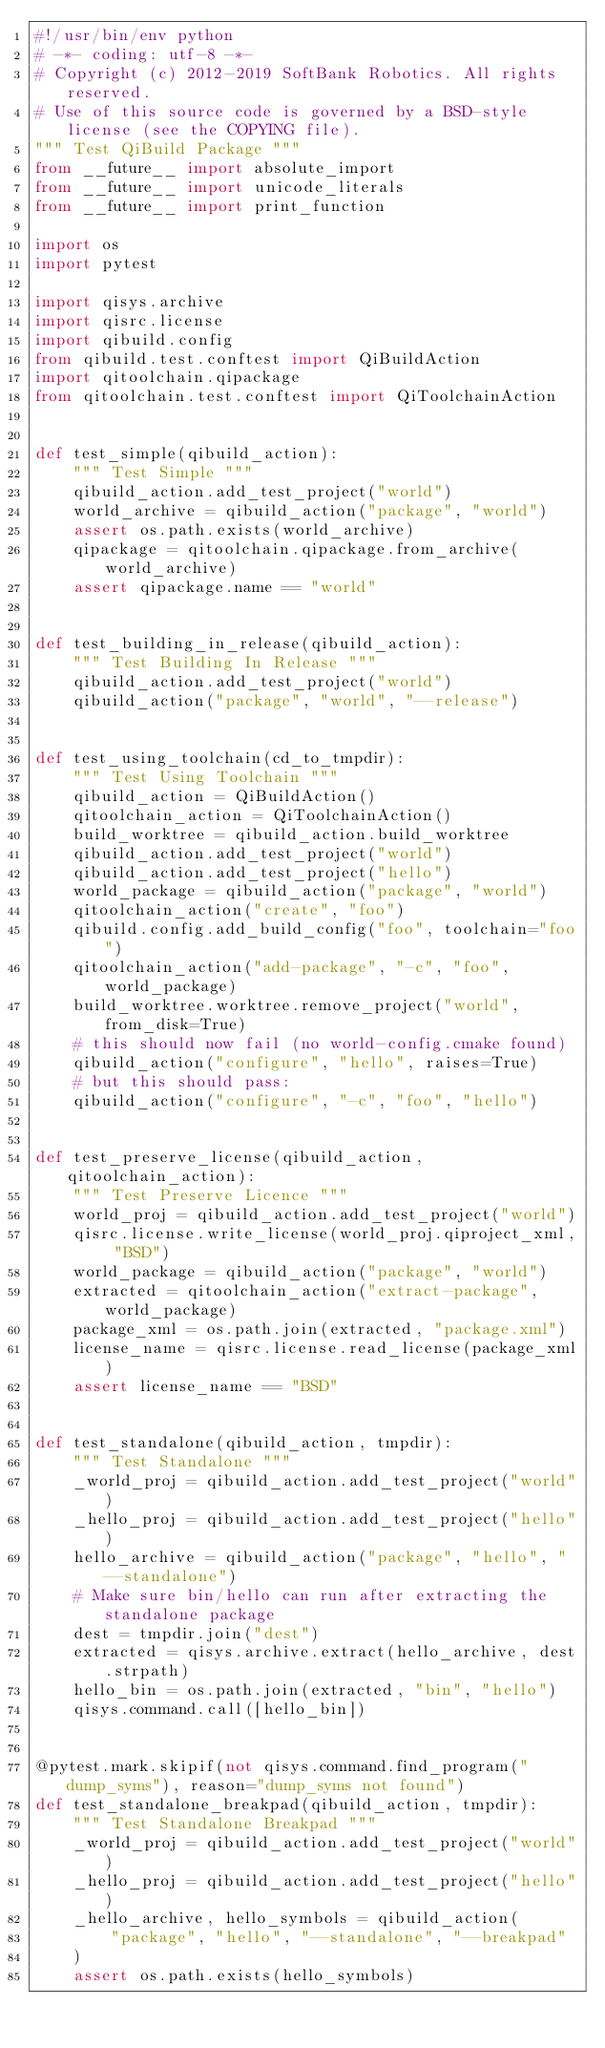Convert code to text. <code><loc_0><loc_0><loc_500><loc_500><_Python_>#!/usr/bin/env python
# -*- coding: utf-8 -*-
# Copyright (c) 2012-2019 SoftBank Robotics. All rights reserved.
# Use of this source code is governed by a BSD-style license (see the COPYING file).
""" Test QiBuild Package """
from __future__ import absolute_import
from __future__ import unicode_literals
from __future__ import print_function

import os
import pytest

import qisys.archive
import qisrc.license
import qibuild.config
from qibuild.test.conftest import QiBuildAction
import qitoolchain.qipackage
from qitoolchain.test.conftest import QiToolchainAction


def test_simple(qibuild_action):
    """ Test Simple """
    qibuild_action.add_test_project("world")
    world_archive = qibuild_action("package", "world")
    assert os.path.exists(world_archive)
    qipackage = qitoolchain.qipackage.from_archive(world_archive)
    assert qipackage.name == "world"


def test_building_in_release(qibuild_action):
    """ Test Building In Release """
    qibuild_action.add_test_project("world")
    qibuild_action("package", "world", "--release")


def test_using_toolchain(cd_to_tmpdir):
    """ Test Using Toolchain """
    qibuild_action = QiBuildAction()
    qitoolchain_action = QiToolchainAction()
    build_worktree = qibuild_action.build_worktree
    qibuild_action.add_test_project("world")
    qibuild_action.add_test_project("hello")
    world_package = qibuild_action("package", "world")
    qitoolchain_action("create", "foo")
    qibuild.config.add_build_config("foo", toolchain="foo")
    qitoolchain_action("add-package", "-c", "foo", world_package)
    build_worktree.worktree.remove_project("world", from_disk=True)
    # this should now fail (no world-config.cmake found)
    qibuild_action("configure", "hello", raises=True)
    # but this should pass:
    qibuild_action("configure", "-c", "foo", "hello")


def test_preserve_license(qibuild_action, qitoolchain_action):
    """ Test Preserve Licence """
    world_proj = qibuild_action.add_test_project("world")
    qisrc.license.write_license(world_proj.qiproject_xml, "BSD")
    world_package = qibuild_action("package", "world")
    extracted = qitoolchain_action("extract-package", world_package)
    package_xml = os.path.join(extracted, "package.xml")
    license_name = qisrc.license.read_license(package_xml)
    assert license_name == "BSD"


def test_standalone(qibuild_action, tmpdir):
    """ Test Standalone """
    _world_proj = qibuild_action.add_test_project("world")
    _hello_proj = qibuild_action.add_test_project("hello")
    hello_archive = qibuild_action("package", "hello", "--standalone")
    # Make sure bin/hello can run after extracting the standalone package
    dest = tmpdir.join("dest")
    extracted = qisys.archive.extract(hello_archive, dest.strpath)
    hello_bin = os.path.join(extracted, "bin", "hello")
    qisys.command.call([hello_bin])


@pytest.mark.skipif(not qisys.command.find_program("dump_syms"), reason="dump_syms not found")
def test_standalone_breakpad(qibuild_action, tmpdir):
    """ Test Standalone Breakpad """
    _world_proj = qibuild_action.add_test_project("world")
    _hello_proj = qibuild_action.add_test_project("hello")
    _hello_archive, hello_symbols = qibuild_action(
        "package", "hello", "--standalone", "--breakpad"
    )
    assert os.path.exists(hello_symbols)
</code> 